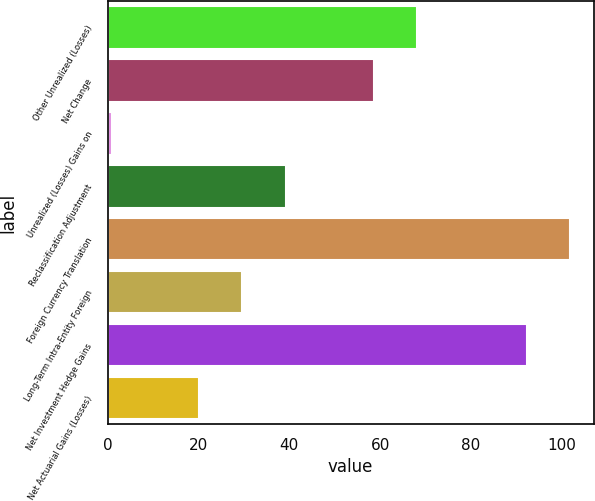Convert chart to OTSL. <chart><loc_0><loc_0><loc_500><loc_500><bar_chart><fcel>Other Unrealized (Losses)<fcel>Net Change<fcel>Unrealized (Losses) Gains on<fcel>Reclassification Adjustment<fcel>Foreign Currency Translation<fcel>Long-Term Intra-Entity Foreign<fcel>Net Investment Hedge Gains<fcel>Net Actuarial Gains (Losses)<nl><fcel>68.16<fcel>58.6<fcel>1<fcel>39.24<fcel>101.86<fcel>29.68<fcel>92.3<fcel>20.12<nl></chart> 